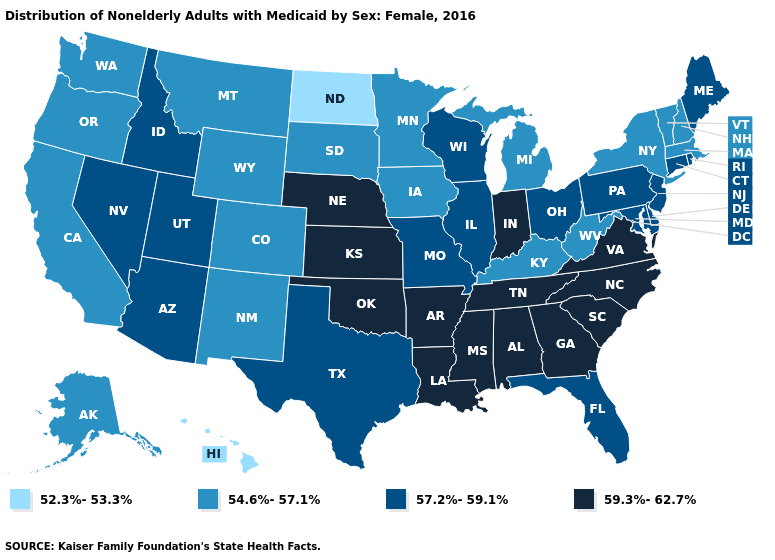Name the states that have a value in the range 54.6%-57.1%?
Quick response, please. Alaska, California, Colorado, Iowa, Kentucky, Massachusetts, Michigan, Minnesota, Montana, New Hampshire, New Mexico, New York, Oregon, South Dakota, Vermont, Washington, West Virginia, Wyoming. Does Arkansas have a higher value than Illinois?
Quick response, please. Yes. What is the highest value in the West ?
Answer briefly. 57.2%-59.1%. What is the lowest value in the USA?
Write a very short answer. 52.3%-53.3%. What is the highest value in states that border Maryland?
Give a very brief answer. 59.3%-62.7%. What is the value of Indiana?
Write a very short answer. 59.3%-62.7%. What is the lowest value in the USA?
Write a very short answer. 52.3%-53.3%. What is the value of New Hampshire?
Write a very short answer. 54.6%-57.1%. Name the states that have a value in the range 52.3%-53.3%?
Write a very short answer. Hawaii, North Dakota. Does Kansas have the same value as Georgia?
Quick response, please. Yes. Name the states that have a value in the range 57.2%-59.1%?
Be succinct. Arizona, Connecticut, Delaware, Florida, Idaho, Illinois, Maine, Maryland, Missouri, Nevada, New Jersey, Ohio, Pennsylvania, Rhode Island, Texas, Utah, Wisconsin. What is the value of Nebraska?
Concise answer only. 59.3%-62.7%. Which states have the lowest value in the West?
Give a very brief answer. Hawaii. What is the value of Alaska?
Short answer required. 54.6%-57.1%. Does West Virginia have the lowest value in the South?
Quick response, please. Yes. 